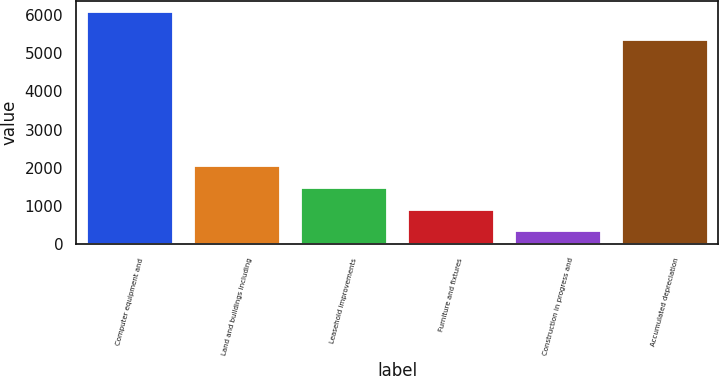<chart> <loc_0><loc_0><loc_500><loc_500><bar_chart><fcel>Computer equipment and<fcel>Land and buildings including<fcel>Leasehold improvements<fcel>Furniture and fixtures<fcel>Construction in progress and<fcel>Accumulated depreciation<nl><fcel>6073<fcel>2053.6<fcel>1479.4<fcel>905.2<fcel>331<fcel>5344<nl></chart> 